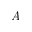<formula> <loc_0><loc_0><loc_500><loc_500>A</formula> 